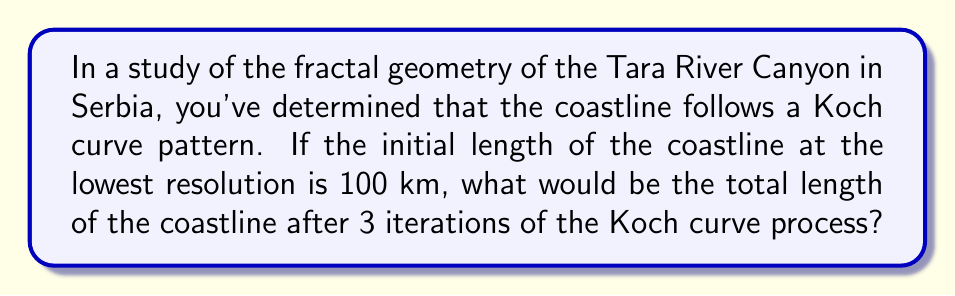Show me your answer to this math problem. Let's approach this step-by-step:

1) The Koch curve is a fractal that increases in length with each iteration. 

2) In each iteration, every line segment is divided into three equal parts, and the middle segment is replaced by two segments forming an equilateral triangle.

3) This process increases the length by a factor of 4/3 in each iteration.

4) We can express this mathematically as:

   $$L_n = L_0 \cdot (\frac{4}{3})^n$$

   Where $L_n$ is the length after n iterations, and $L_0$ is the initial length.

5) In our case:
   $L_0 = 100$ km (initial length)
   $n = 3$ (number of iterations)

6) Plugging these values into our equation:

   $$L_3 = 100 \cdot (\frac{4}{3})^3$$

7) Let's calculate this:
   $$L_3 = 100 \cdot (\frac{64}{27})$$
   $$L_3 = \frac{6400}{27}$$
   $$L_3 \approx 237.04$$

Therefore, after 3 iterations, the coastline length would be approximately 237.04 km.
Answer: 237.04 km 